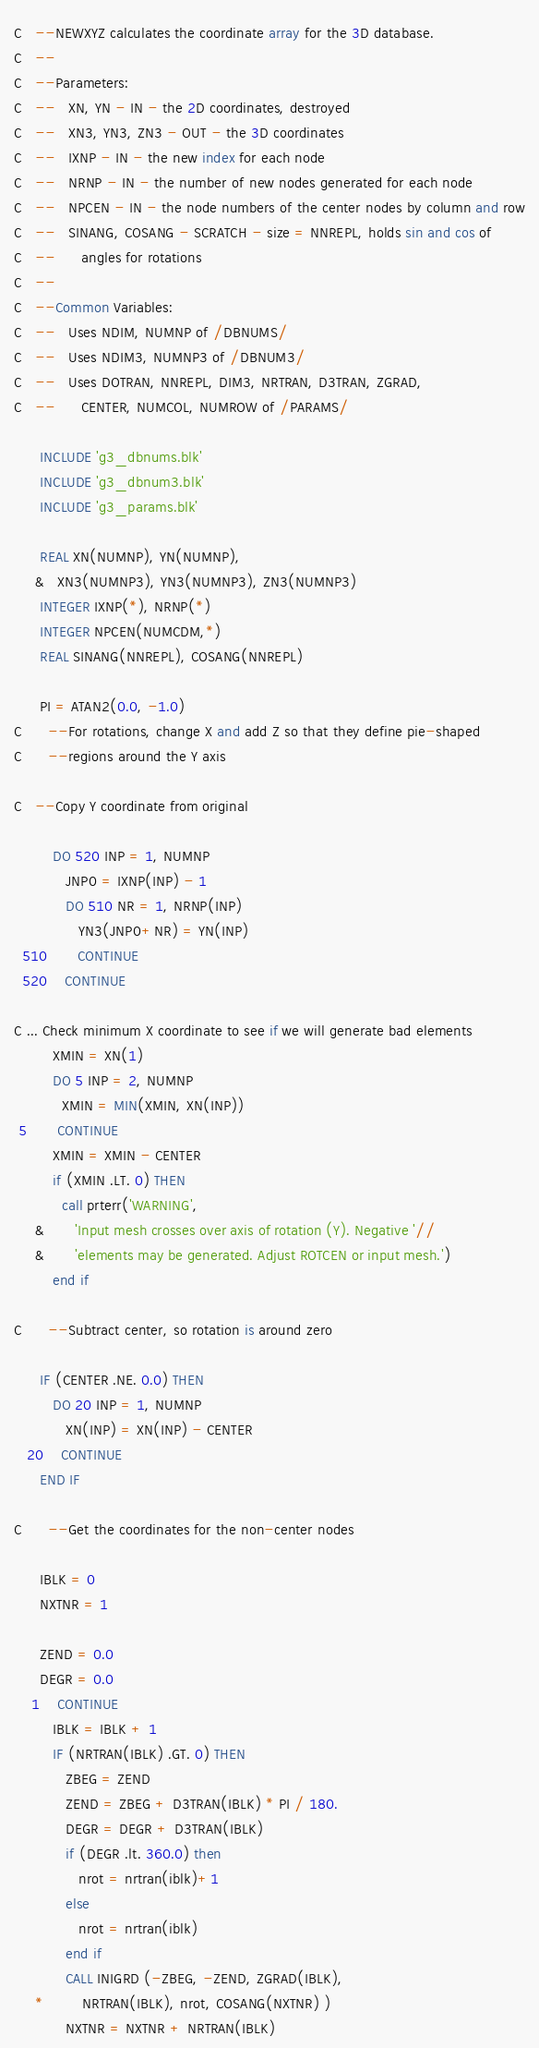<code> <loc_0><loc_0><loc_500><loc_500><_FORTRAN_>C   --NEWXYZ calculates the coordinate array for the 3D database.
C   --
C   --Parameters:
C   --   XN, YN - IN - the 2D coordinates, destroyed
C   --   XN3, YN3, ZN3 - OUT - the 3D coordinates
C   --   IXNP - IN - the new index for each node
C   --   NRNP - IN - the number of new nodes generated for each node
C   --   NPCEN - IN - the node numbers of the center nodes by column and row
C   --   SINANG, COSANG - SCRATCH - size = NNREPL, holds sin and cos of
C   --      angles for rotations
C   --
C   --Common Variables:
C   --   Uses NDIM, NUMNP of /DBNUMS/
C   --   Uses NDIM3, NUMNP3 of /DBNUM3/
C   --   Uses DOTRAN, NNREPL, DIM3, NRTRAN, D3TRAN, ZGRAD,
C   --      CENTER, NUMCOL, NUMROW of /PARAMS/

      INCLUDE 'g3_dbnums.blk'
      INCLUDE 'g3_dbnum3.blk'
      INCLUDE 'g3_params.blk'

      REAL XN(NUMNP), YN(NUMNP),
     &   XN3(NUMNP3), YN3(NUMNP3), ZN3(NUMNP3)
      INTEGER IXNP(*), NRNP(*)
      INTEGER NPCEN(NUMCDM,*)
      REAL SINANG(NNREPL), COSANG(NNREPL)

      PI = ATAN2(0.0, -1.0)
C      --For rotations, change X and add Z so that they define pie-shaped
C      --regions around the Y axis

C   --Copy Y coordinate from original

         DO 520 INP = 1, NUMNP
            JNP0 = IXNP(INP) - 1
            DO 510 NR = 1, NRNP(INP)
               YN3(JNP0+NR) = YN(INP)
  510       CONTINUE
  520    CONTINUE

C ... Check minimum X coordinate to see if we will generate bad elements
         XMIN = XN(1)
         DO 5 INP = 2, NUMNP
           XMIN = MIN(XMIN, XN(INP))
 5       CONTINUE
         XMIN = XMIN - CENTER
         if (XMIN .LT. 0) THEN
           call prterr('WARNING',
     &       'Input mesh crosses over axis of rotation (Y). Negative '//
     &       'elements may be generated. Adjust ROTCEN or input mesh.')
         end if

C      --Subtract center, so rotation is around zero

      IF (CENTER .NE. 0.0) THEN
         DO 20 INP = 1, NUMNP
            XN(INP) = XN(INP) - CENTER
   20    CONTINUE
      END IF

C      --Get the coordinates for the non-center nodes

      IBLK = 0
      NXTNR = 1

      ZEND = 0.0
      DEGR = 0.0
    1    CONTINUE
         IBLK = IBLK + 1
         IF (NRTRAN(IBLK) .GT. 0) THEN
            ZBEG = ZEND
            ZEND = ZBEG + D3TRAN(IBLK) * PI / 180.
            DEGR = DEGR + D3TRAN(IBLK)
            if (DEGR .lt. 360.0) then
               nrot = nrtran(iblk)+1
            else
               nrot = nrtran(iblk)
            end if
            CALL INIGRD (-ZBEG, -ZEND, ZGRAD(IBLK),
     *         NRTRAN(IBLK), nrot, COSANG(NXTNR) )
            NXTNR = NXTNR + NRTRAN(IBLK)</code> 